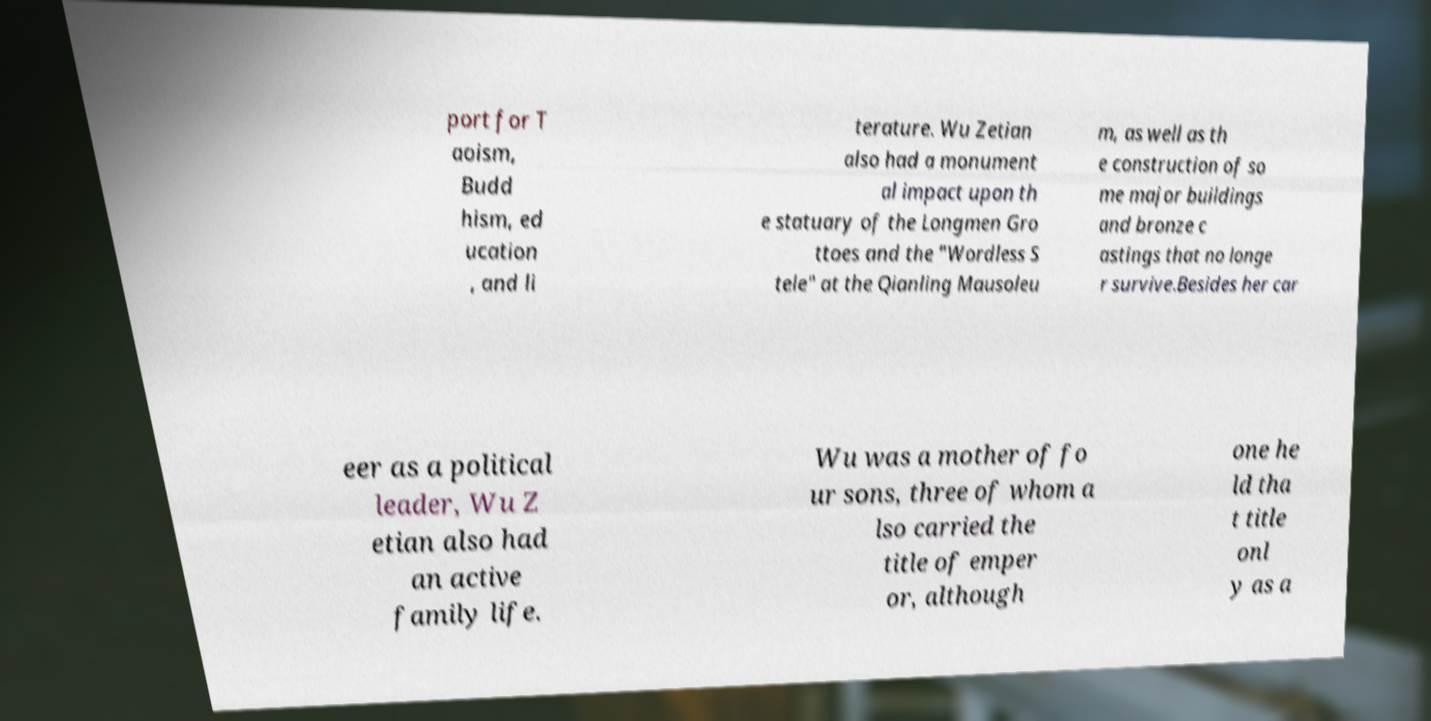Can you accurately transcribe the text from the provided image for me? port for T aoism, Budd hism, ed ucation , and li terature. Wu Zetian also had a monument al impact upon th e statuary of the Longmen Gro ttoes and the "Wordless S tele" at the Qianling Mausoleu m, as well as th e construction of so me major buildings and bronze c astings that no longe r survive.Besides her car eer as a political leader, Wu Z etian also had an active family life. Wu was a mother of fo ur sons, three of whom a lso carried the title of emper or, although one he ld tha t title onl y as a 